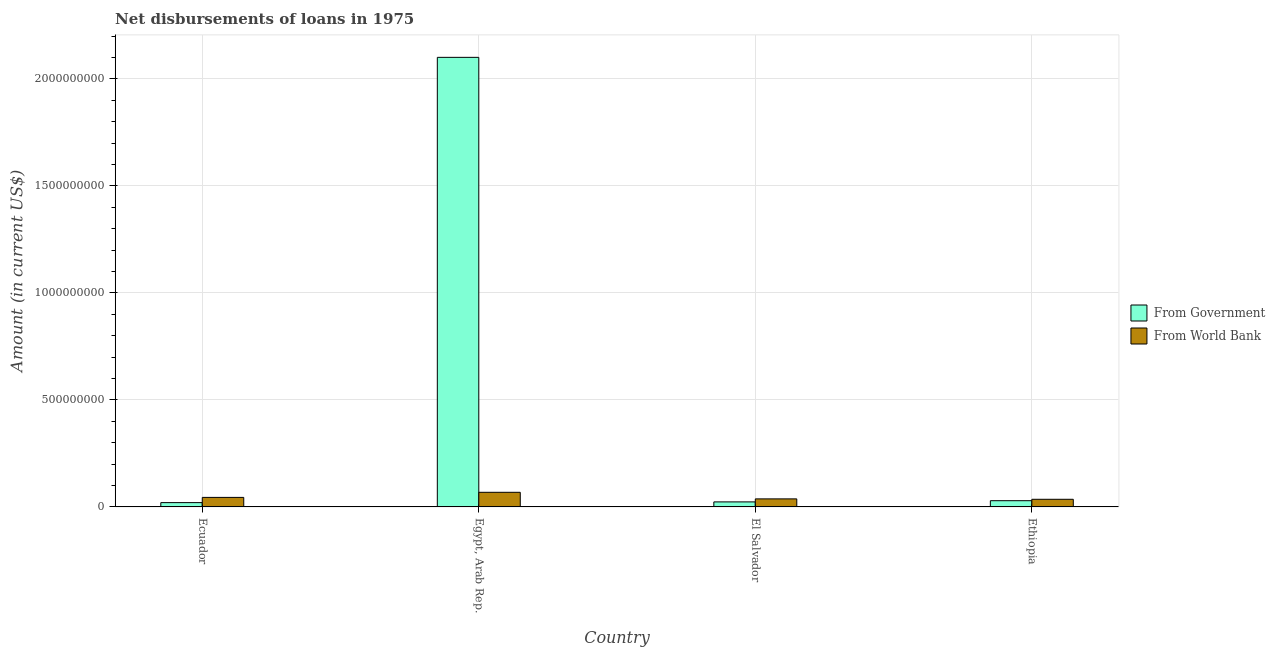How many groups of bars are there?
Provide a short and direct response. 4. How many bars are there on the 4th tick from the right?
Your answer should be very brief. 2. What is the label of the 4th group of bars from the left?
Your answer should be very brief. Ethiopia. What is the net disbursements of loan from world bank in Ethiopia?
Provide a short and direct response. 3.57e+07. Across all countries, what is the maximum net disbursements of loan from government?
Provide a short and direct response. 2.10e+09. Across all countries, what is the minimum net disbursements of loan from world bank?
Keep it short and to the point. 3.57e+07. In which country was the net disbursements of loan from world bank maximum?
Keep it short and to the point. Egypt, Arab Rep. In which country was the net disbursements of loan from government minimum?
Ensure brevity in your answer.  Ecuador. What is the total net disbursements of loan from government in the graph?
Make the answer very short. 2.17e+09. What is the difference between the net disbursements of loan from government in Ecuador and that in Egypt, Arab Rep.?
Provide a short and direct response. -2.08e+09. What is the difference between the net disbursements of loan from world bank in Ecuador and the net disbursements of loan from government in El Salvador?
Make the answer very short. 2.10e+07. What is the average net disbursements of loan from government per country?
Keep it short and to the point. 5.43e+08. What is the difference between the net disbursements of loan from government and net disbursements of loan from world bank in Egypt, Arab Rep.?
Keep it short and to the point. 2.03e+09. In how many countries, is the net disbursements of loan from world bank greater than 1800000000 US$?
Give a very brief answer. 0. What is the ratio of the net disbursements of loan from government in El Salvador to that in Ethiopia?
Make the answer very short. 0.81. What is the difference between the highest and the second highest net disbursements of loan from world bank?
Offer a terse response. 2.38e+07. What is the difference between the highest and the lowest net disbursements of loan from world bank?
Offer a very short reply. 3.26e+07. In how many countries, is the net disbursements of loan from world bank greater than the average net disbursements of loan from world bank taken over all countries?
Offer a terse response. 1. What does the 2nd bar from the left in Ecuador represents?
Give a very brief answer. From World Bank. What does the 2nd bar from the right in Egypt, Arab Rep. represents?
Give a very brief answer. From Government. How many bars are there?
Provide a short and direct response. 8. How many countries are there in the graph?
Make the answer very short. 4. What is the difference between two consecutive major ticks on the Y-axis?
Your response must be concise. 5.00e+08. Does the graph contain any zero values?
Your answer should be compact. No. How many legend labels are there?
Make the answer very short. 2. What is the title of the graph?
Keep it short and to the point. Net disbursements of loans in 1975. What is the Amount (in current US$) in From Government in Ecuador?
Your response must be concise. 2.01e+07. What is the Amount (in current US$) in From World Bank in Ecuador?
Provide a short and direct response. 4.45e+07. What is the Amount (in current US$) in From Government in Egypt, Arab Rep.?
Offer a terse response. 2.10e+09. What is the Amount (in current US$) of From World Bank in Egypt, Arab Rep.?
Give a very brief answer. 6.83e+07. What is the Amount (in current US$) of From Government in El Salvador?
Your answer should be very brief. 2.35e+07. What is the Amount (in current US$) of From World Bank in El Salvador?
Offer a very short reply. 3.76e+07. What is the Amount (in current US$) of From Government in Ethiopia?
Offer a very short reply. 2.91e+07. What is the Amount (in current US$) in From World Bank in Ethiopia?
Your answer should be compact. 3.57e+07. Across all countries, what is the maximum Amount (in current US$) of From Government?
Your answer should be compact. 2.10e+09. Across all countries, what is the maximum Amount (in current US$) in From World Bank?
Keep it short and to the point. 6.83e+07. Across all countries, what is the minimum Amount (in current US$) in From Government?
Keep it short and to the point. 2.01e+07. Across all countries, what is the minimum Amount (in current US$) of From World Bank?
Your answer should be very brief. 3.57e+07. What is the total Amount (in current US$) in From Government in the graph?
Give a very brief answer. 2.17e+09. What is the total Amount (in current US$) of From World Bank in the graph?
Keep it short and to the point. 1.86e+08. What is the difference between the Amount (in current US$) of From Government in Ecuador and that in Egypt, Arab Rep.?
Offer a terse response. -2.08e+09. What is the difference between the Amount (in current US$) in From World Bank in Ecuador and that in Egypt, Arab Rep.?
Your response must be concise. -2.38e+07. What is the difference between the Amount (in current US$) in From Government in Ecuador and that in El Salvador?
Your response must be concise. -3.42e+06. What is the difference between the Amount (in current US$) in From World Bank in Ecuador and that in El Salvador?
Your answer should be very brief. 6.97e+06. What is the difference between the Amount (in current US$) of From Government in Ecuador and that in Ethiopia?
Offer a very short reply. -8.98e+06. What is the difference between the Amount (in current US$) in From World Bank in Ecuador and that in Ethiopia?
Your response must be concise. 8.82e+06. What is the difference between the Amount (in current US$) in From Government in Egypt, Arab Rep. and that in El Salvador?
Provide a succinct answer. 2.08e+09. What is the difference between the Amount (in current US$) in From World Bank in Egypt, Arab Rep. and that in El Salvador?
Provide a short and direct response. 3.07e+07. What is the difference between the Amount (in current US$) in From Government in Egypt, Arab Rep. and that in Ethiopia?
Offer a very short reply. 2.07e+09. What is the difference between the Amount (in current US$) of From World Bank in Egypt, Arab Rep. and that in Ethiopia?
Provide a succinct answer. 3.26e+07. What is the difference between the Amount (in current US$) of From Government in El Salvador and that in Ethiopia?
Provide a succinct answer. -5.56e+06. What is the difference between the Amount (in current US$) in From World Bank in El Salvador and that in Ethiopia?
Ensure brevity in your answer.  1.85e+06. What is the difference between the Amount (in current US$) in From Government in Ecuador and the Amount (in current US$) in From World Bank in Egypt, Arab Rep.?
Offer a very short reply. -4.82e+07. What is the difference between the Amount (in current US$) of From Government in Ecuador and the Amount (in current US$) of From World Bank in El Salvador?
Your answer should be compact. -1.75e+07. What is the difference between the Amount (in current US$) in From Government in Ecuador and the Amount (in current US$) in From World Bank in Ethiopia?
Provide a short and direct response. -1.56e+07. What is the difference between the Amount (in current US$) of From Government in Egypt, Arab Rep. and the Amount (in current US$) of From World Bank in El Salvador?
Your answer should be compact. 2.06e+09. What is the difference between the Amount (in current US$) in From Government in Egypt, Arab Rep. and the Amount (in current US$) in From World Bank in Ethiopia?
Offer a terse response. 2.06e+09. What is the difference between the Amount (in current US$) of From Government in El Salvador and the Amount (in current US$) of From World Bank in Ethiopia?
Provide a short and direct response. -1.22e+07. What is the average Amount (in current US$) of From Government per country?
Offer a very short reply. 5.43e+08. What is the average Amount (in current US$) of From World Bank per country?
Keep it short and to the point. 4.65e+07. What is the difference between the Amount (in current US$) in From Government and Amount (in current US$) in From World Bank in Ecuador?
Your answer should be very brief. -2.44e+07. What is the difference between the Amount (in current US$) of From Government and Amount (in current US$) of From World Bank in Egypt, Arab Rep.?
Ensure brevity in your answer.  2.03e+09. What is the difference between the Amount (in current US$) in From Government and Amount (in current US$) in From World Bank in El Salvador?
Offer a terse response. -1.40e+07. What is the difference between the Amount (in current US$) of From Government and Amount (in current US$) of From World Bank in Ethiopia?
Give a very brief answer. -6.62e+06. What is the ratio of the Amount (in current US$) of From Government in Ecuador to that in Egypt, Arab Rep.?
Keep it short and to the point. 0.01. What is the ratio of the Amount (in current US$) of From World Bank in Ecuador to that in Egypt, Arab Rep.?
Your answer should be compact. 0.65. What is the ratio of the Amount (in current US$) of From Government in Ecuador to that in El Salvador?
Your answer should be very brief. 0.85. What is the ratio of the Amount (in current US$) of From World Bank in Ecuador to that in El Salvador?
Your answer should be compact. 1.19. What is the ratio of the Amount (in current US$) in From Government in Ecuador to that in Ethiopia?
Provide a short and direct response. 0.69. What is the ratio of the Amount (in current US$) in From World Bank in Ecuador to that in Ethiopia?
Offer a very short reply. 1.25. What is the ratio of the Amount (in current US$) in From Government in Egypt, Arab Rep. to that in El Salvador?
Ensure brevity in your answer.  89.23. What is the ratio of the Amount (in current US$) of From World Bank in Egypt, Arab Rep. to that in El Salvador?
Your answer should be very brief. 1.82. What is the ratio of the Amount (in current US$) of From Government in Egypt, Arab Rep. to that in Ethiopia?
Provide a short and direct response. 72.19. What is the ratio of the Amount (in current US$) in From World Bank in Egypt, Arab Rep. to that in Ethiopia?
Ensure brevity in your answer.  1.91. What is the ratio of the Amount (in current US$) of From Government in El Salvador to that in Ethiopia?
Your response must be concise. 0.81. What is the ratio of the Amount (in current US$) in From World Bank in El Salvador to that in Ethiopia?
Ensure brevity in your answer.  1.05. What is the difference between the highest and the second highest Amount (in current US$) in From Government?
Ensure brevity in your answer.  2.07e+09. What is the difference between the highest and the second highest Amount (in current US$) of From World Bank?
Give a very brief answer. 2.38e+07. What is the difference between the highest and the lowest Amount (in current US$) in From Government?
Your answer should be compact. 2.08e+09. What is the difference between the highest and the lowest Amount (in current US$) of From World Bank?
Give a very brief answer. 3.26e+07. 